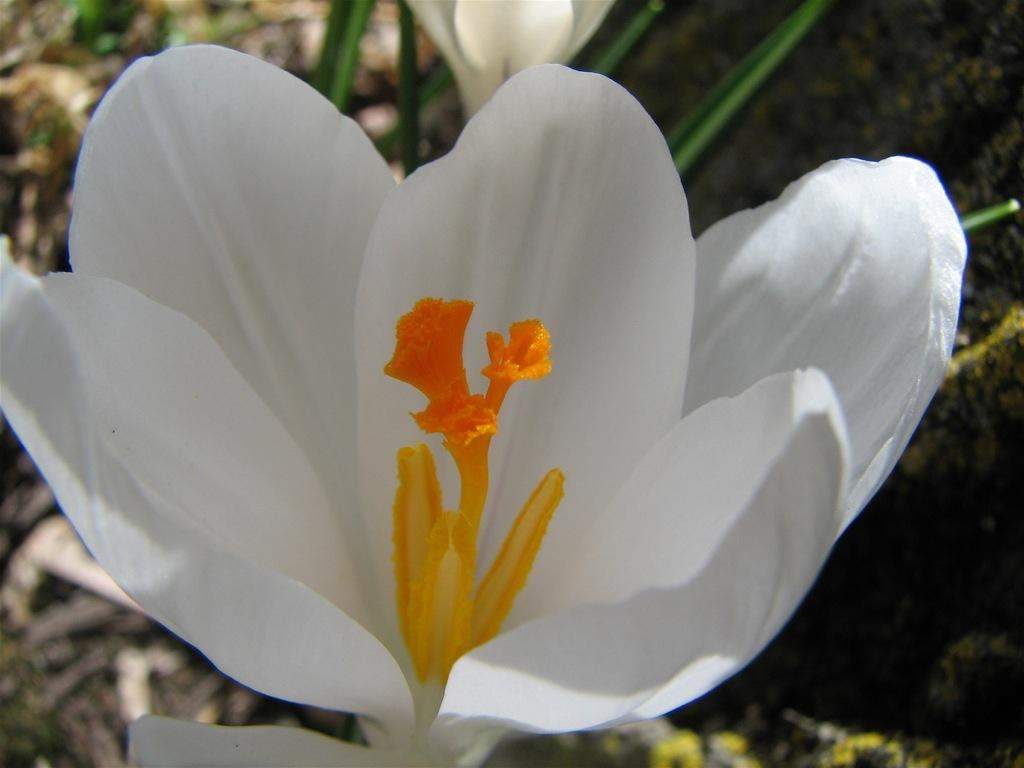What is the main subject of the image? The main subject of the image is a flower. Can you describe the color of the flower? The flower is white and orange in color. What type of crack is visible on the petals of the flower in the image? There is no crack visible on the petals of the flower in the image. 